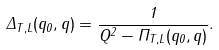Convert formula to latex. <formula><loc_0><loc_0><loc_500><loc_500>\Delta _ { T , L } ( q _ { 0 } , q ) = \frac { 1 } { Q ^ { 2 } - \Pi _ { T , L } ( q _ { 0 } , q ) } .</formula> 